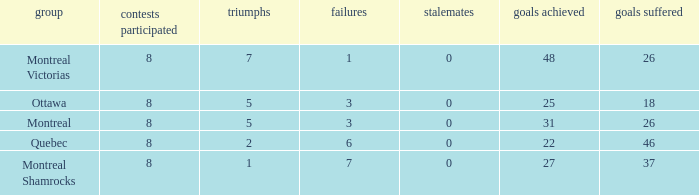How many losses did the team with 22 goals for andmore than 8 games played have? 0.0. Would you be able to parse every entry in this table? {'header': ['group', 'contests participated', 'triumphs', 'failures', 'stalemates', 'goals achieved', 'goals suffered'], 'rows': [['Montreal Victorias', '8', '7', '1', '0', '48', '26'], ['Ottawa', '8', '5', '3', '0', '25', '18'], ['Montreal', '8', '5', '3', '0', '31', '26'], ['Quebec', '8', '2', '6', '0', '22', '46'], ['Montreal Shamrocks', '8', '1', '7', '0', '27', '37']]} 